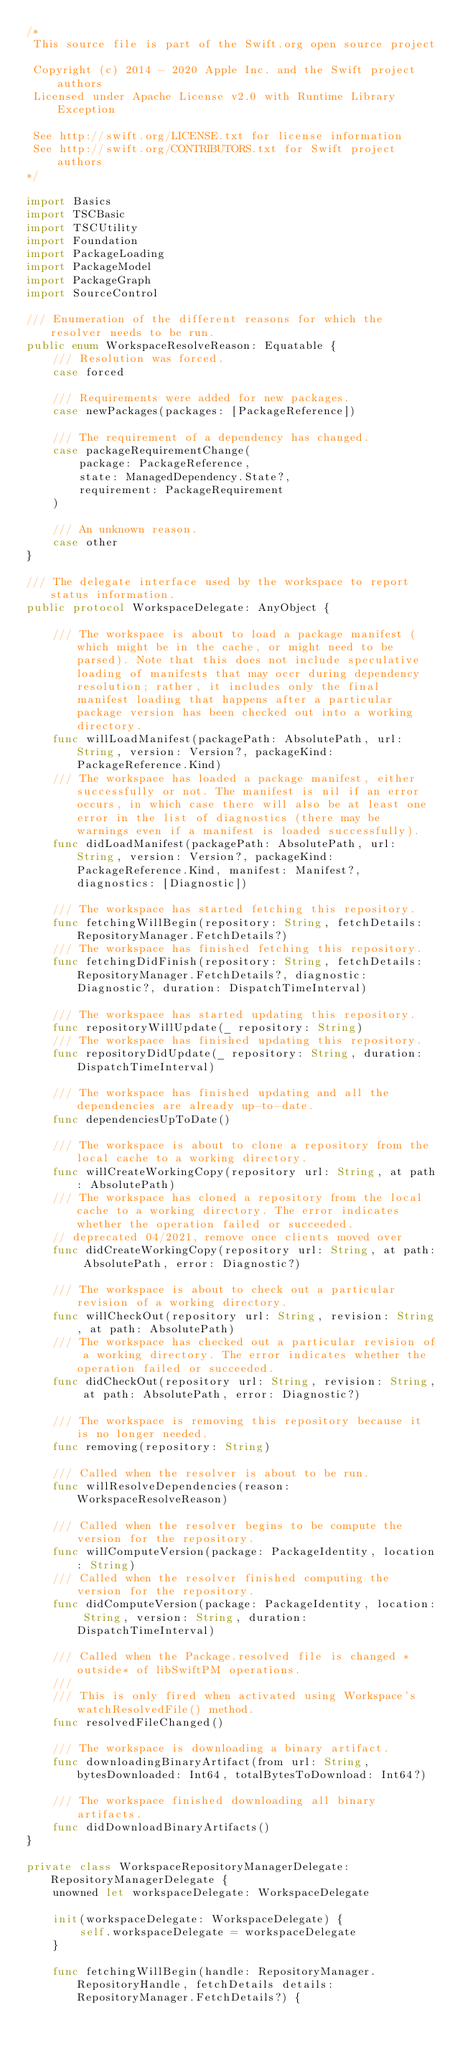<code> <loc_0><loc_0><loc_500><loc_500><_Swift_>/*
 This source file is part of the Swift.org open source project

 Copyright (c) 2014 - 2020 Apple Inc. and the Swift project authors
 Licensed under Apache License v2.0 with Runtime Library Exception

 See http://swift.org/LICENSE.txt for license information
 See http://swift.org/CONTRIBUTORS.txt for Swift project authors
*/

import Basics
import TSCBasic
import TSCUtility
import Foundation
import PackageLoading
import PackageModel
import PackageGraph
import SourceControl

/// Enumeration of the different reasons for which the resolver needs to be run.
public enum WorkspaceResolveReason: Equatable {
    /// Resolution was forced.
    case forced

    /// Requirements were added for new packages.
    case newPackages(packages: [PackageReference])

    /// The requirement of a dependency has changed.
    case packageRequirementChange(
        package: PackageReference,
        state: ManagedDependency.State?,
        requirement: PackageRequirement
    )

    /// An unknown reason.
    case other
}

/// The delegate interface used by the workspace to report status information.
public protocol WorkspaceDelegate: AnyObject {

    /// The workspace is about to load a package manifest (which might be in the cache, or might need to be parsed). Note that this does not include speculative loading of manifests that may occr during dependency resolution; rather, it includes only the final manifest loading that happens after a particular package version has been checked out into a working directory.
    func willLoadManifest(packagePath: AbsolutePath, url: String, version: Version?, packageKind: PackageReference.Kind)
    /// The workspace has loaded a package manifest, either successfully or not. The manifest is nil if an error occurs, in which case there will also be at least one error in the list of diagnostics (there may be warnings even if a manifest is loaded successfully).
    func didLoadManifest(packagePath: AbsolutePath, url: String, version: Version?, packageKind: PackageReference.Kind, manifest: Manifest?, diagnostics: [Diagnostic])

    /// The workspace has started fetching this repository.
    func fetchingWillBegin(repository: String, fetchDetails: RepositoryManager.FetchDetails?)
    /// The workspace has finished fetching this repository.
    func fetchingDidFinish(repository: String, fetchDetails: RepositoryManager.FetchDetails?, diagnostic: Diagnostic?, duration: DispatchTimeInterval)

    /// The workspace has started updating this repository.
    func repositoryWillUpdate(_ repository: String)
    /// The workspace has finished updating this repository.
    func repositoryDidUpdate(_ repository: String, duration: DispatchTimeInterval)

    /// The workspace has finished updating and all the dependencies are already up-to-date.
    func dependenciesUpToDate()

    /// The workspace is about to clone a repository from the local cache to a working directory.
    func willCreateWorkingCopy(repository url: String, at path: AbsolutePath)
    /// The workspace has cloned a repository from the local cache to a working directory. The error indicates whether the operation failed or succeeded.
    // deprecated 04/2021, remove once clients moved over
    func didCreateWorkingCopy(repository url: String, at path: AbsolutePath, error: Diagnostic?)

    /// The workspace is about to check out a particular revision of a working directory.
    func willCheckOut(repository url: String, revision: String, at path: AbsolutePath)
    /// The workspace has checked out a particular revision of a working directory. The error indicates whether the operation failed or succeeded.
    func didCheckOut(repository url: String, revision: String, at path: AbsolutePath, error: Diagnostic?)

    /// The workspace is removing this repository because it is no longer needed.
    func removing(repository: String)

    /// Called when the resolver is about to be run.
    func willResolveDependencies(reason: WorkspaceResolveReason)

    /// Called when the resolver begins to be compute the version for the repository.
    func willComputeVersion(package: PackageIdentity, location: String)
    /// Called when the resolver finished computing the version for the repository.
    func didComputeVersion(package: PackageIdentity, location: String, version: String, duration: DispatchTimeInterval)

    /// Called when the Package.resolved file is changed *outside* of libSwiftPM operations.
    ///
    /// This is only fired when activated using Workspace's watchResolvedFile() method.
    func resolvedFileChanged()

    /// The workspace is downloading a binary artifact.
    func downloadingBinaryArtifact(from url: String, bytesDownloaded: Int64, totalBytesToDownload: Int64?)

    /// The workspace finished downloading all binary artifacts.
    func didDownloadBinaryArtifacts()
}

private class WorkspaceRepositoryManagerDelegate: RepositoryManagerDelegate {
    unowned let workspaceDelegate: WorkspaceDelegate

    init(workspaceDelegate: WorkspaceDelegate) {
        self.workspaceDelegate = workspaceDelegate
    }

    func fetchingWillBegin(handle: RepositoryManager.RepositoryHandle, fetchDetails details: RepositoryManager.FetchDetails?) {</code> 